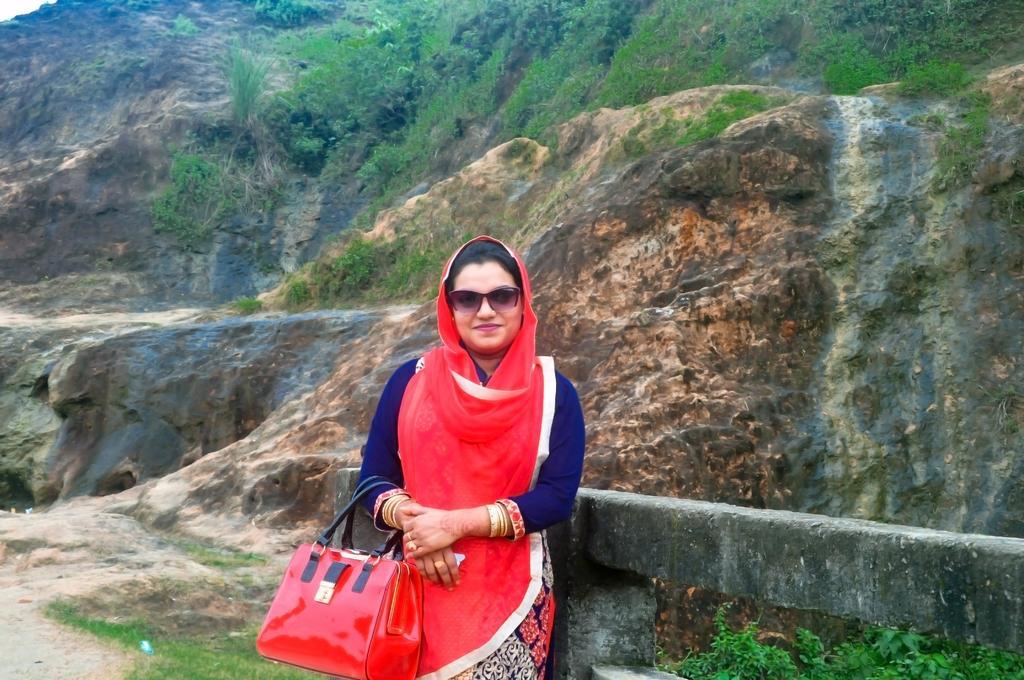In one or two sentences, can you explain what this image depicts? This is the woman standing and smiling. She is holding red handbag. She wore red dupatta with blue dress and goggles. At background I can see small plants. This looks like a hill. 